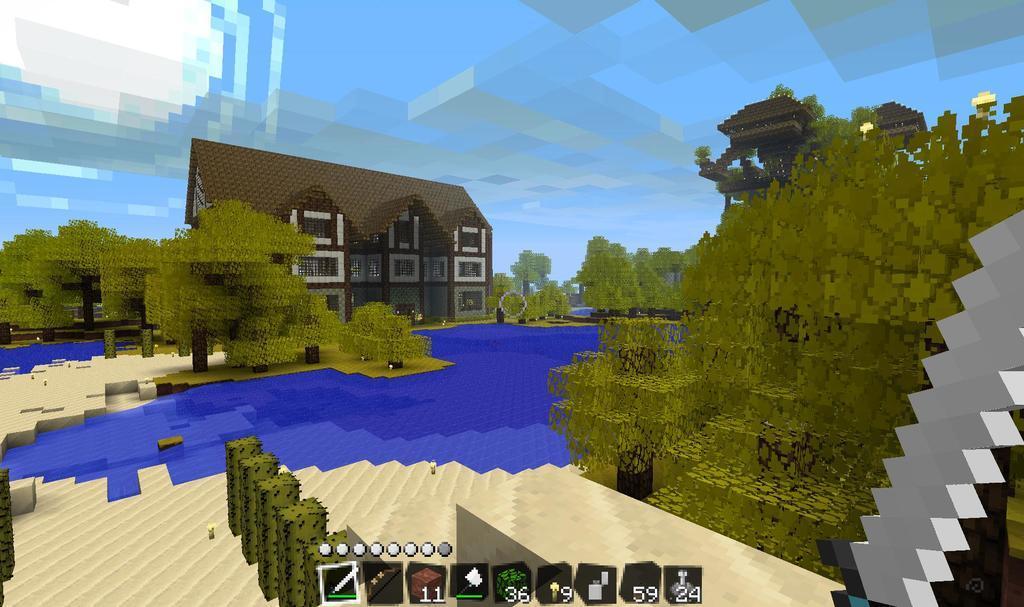Please provide a concise description of this image. Here this picture is a animated image, in which we can see a animated house, plants, trees present over there. 